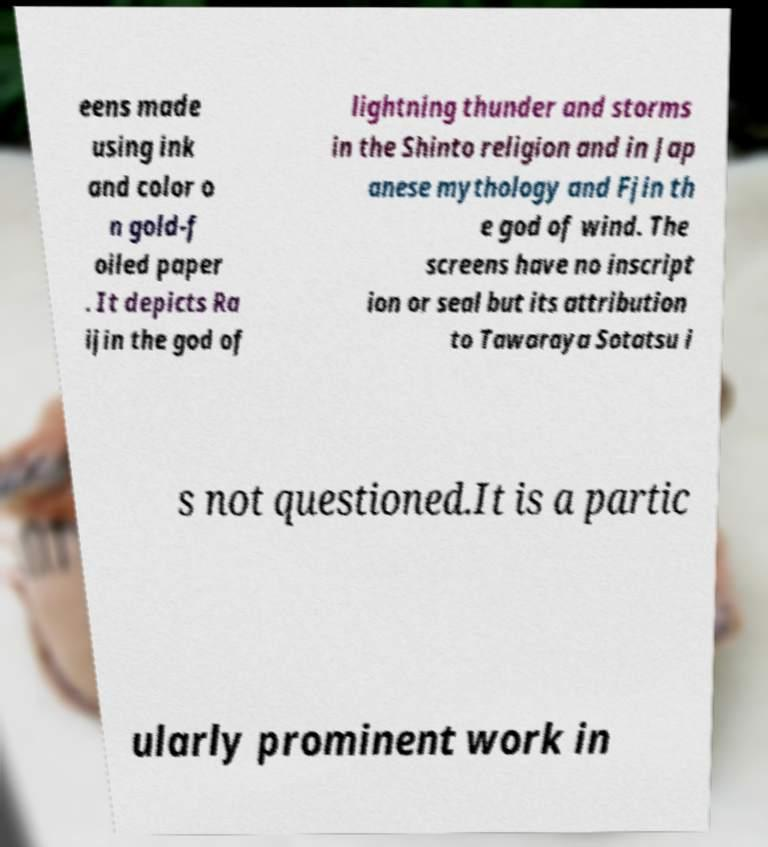I need the written content from this picture converted into text. Can you do that? eens made using ink and color o n gold-f oiled paper . It depicts Ra ijin the god of lightning thunder and storms in the Shinto religion and in Jap anese mythology and Fjin th e god of wind. The screens have no inscript ion or seal but its attribution to Tawaraya Sotatsu i s not questioned.It is a partic ularly prominent work in 